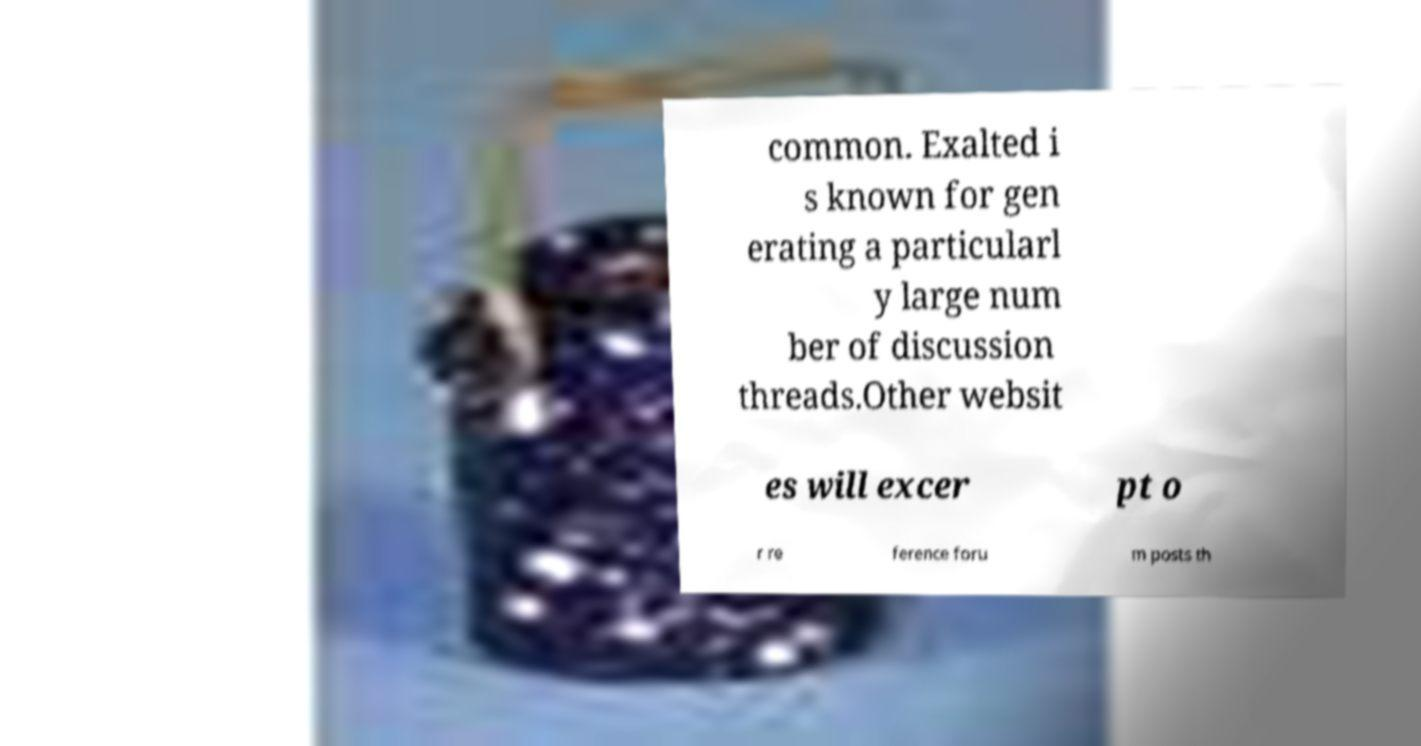Please read and relay the text visible in this image. What does it say? common. Exalted i s known for gen erating a particularl y large num ber of discussion threads.Other websit es will excer pt o r re ference foru m posts th 